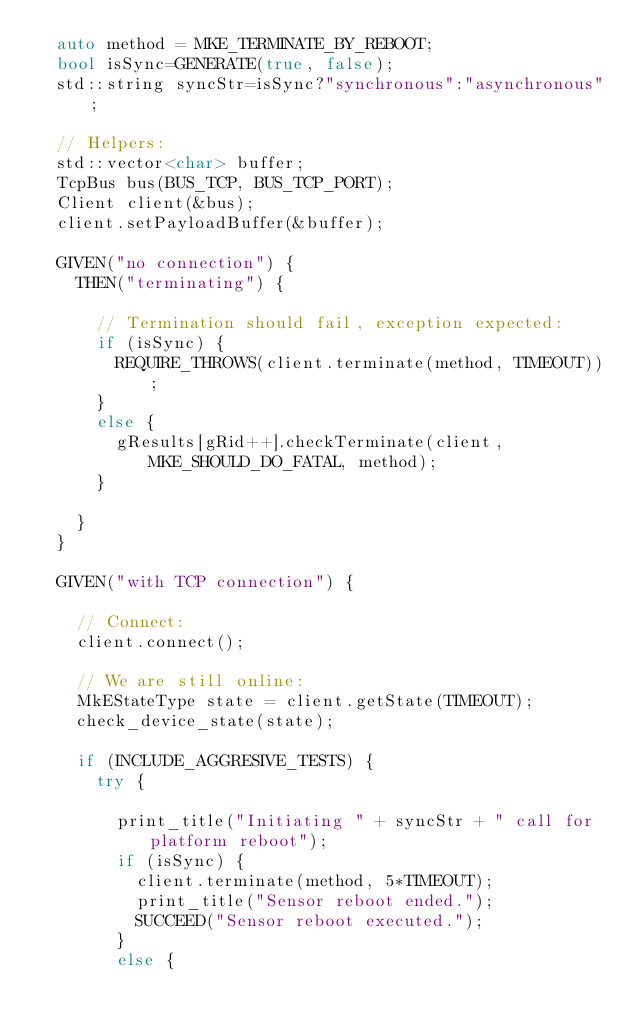<code> <loc_0><loc_0><loc_500><loc_500><_C++_>  auto method = MKE_TERMINATE_BY_REBOOT;
  bool isSync=GENERATE(true, false);
  std::string syncStr=isSync?"synchronous":"asynchronous";

  // Helpers:
  std::vector<char> buffer;
  TcpBus bus(BUS_TCP, BUS_TCP_PORT);
  Client client(&bus);
  client.setPayloadBuffer(&buffer); 

  GIVEN("no connection") {
    THEN("terminating") {

      // Termination should fail, exception expected:
      if (isSync) {
        REQUIRE_THROWS(client.terminate(method, TIMEOUT));
      }
      else {
        gResults[gRid++].checkTerminate(client, MKE_SHOULD_DO_FATAL, method); 
      }

    } 
  }
  
  GIVEN("with TCP connection") {
  
    // Connect:
    client.connect(); 

    // We are still online:
    MkEStateType state = client.getState(TIMEOUT);
    check_device_state(state);

    if (INCLUDE_AGGRESIVE_TESTS) { 
      try {

        print_title("Initiating " + syncStr + " call for platform reboot"); 
        if (isSync) {
          client.terminate(method, 5*TIMEOUT);
          print_title("Sensor reboot ended.");
          SUCCEED("Sensor reboot executed.");
        }
        else {</code> 